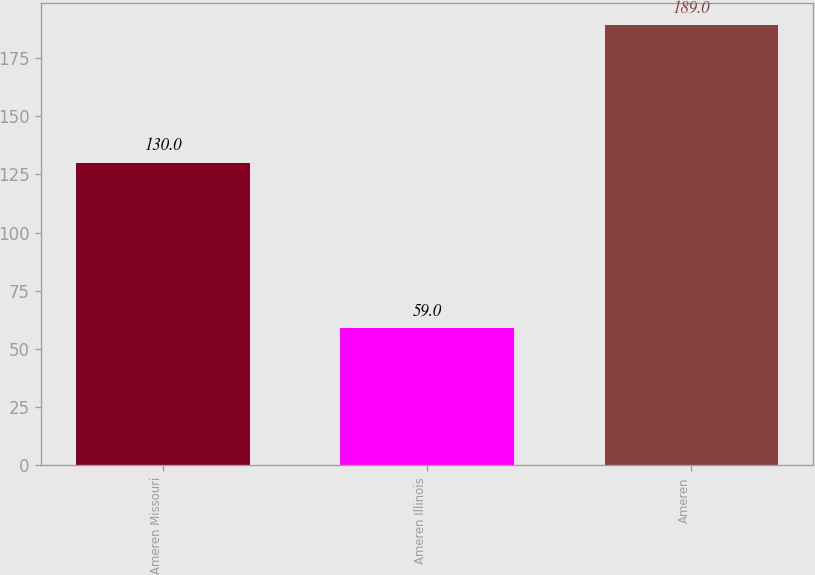Convert chart to OTSL. <chart><loc_0><loc_0><loc_500><loc_500><bar_chart><fcel>Ameren Missouri<fcel>Ameren Illinois<fcel>Ameren<nl><fcel>130<fcel>59<fcel>189<nl></chart> 